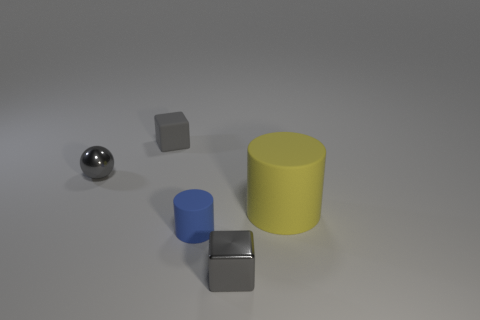Add 3 blue cylinders. How many objects exist? 8 Subtract 1 blocks. How many blocks are left? 1 Subtract all cylinders. How many objects are left? 3 Subtract all small matte spheres. Subtract all blue cylinders. How many objects are left? 4 Add 2 gray metal balls. How many gray metal balls are left? 3 Add 1 tiny blue objects. How many tiny blue objects exist? 2 Subtract 0 cyan cylinders. How many objects are left? 5 Subtract all red cylinders. Subtract all purple cubes. How many cylinders are left? 2 Subtract all green cubes. How many cyan cylinders are left? 0 